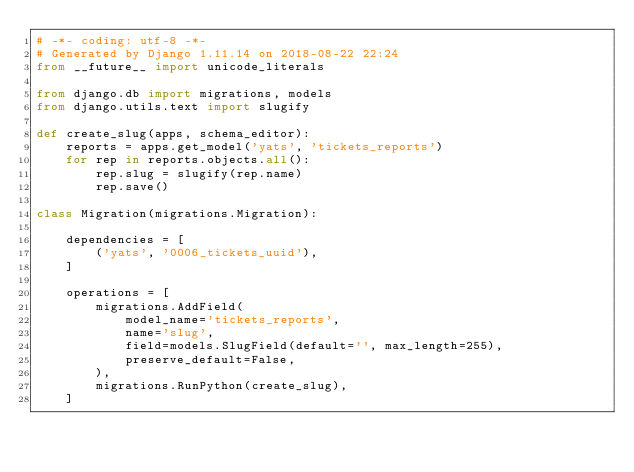Convert code to text. <code><loc_0><loc_0><loc_500><loc_500><_Python_># -*- coding: utf-8 -*-
# Generated by Django 1.11.14 on 2018-08-22 22:24
from __future__ import unicode_literals

from django.db import migrations, models
from django.utils.text import slugify

def create_slug(apps, schema_editor):
    reports = apps.get_model('yats', 'tickets_reports')
    for rep in reports.objects.all():
        rep.slug = slugify(rep.name)
        rep.save()

class Migration(migrations.Migration):

    dependencies = [
        ('yats', '0006_tickets_uuid'),
    ]

    operations = [
        migrations.AddField(
            model_name='tickets_reports',
            name='slug',
            field=models.SlugField(default='', max_length=255),
            preserve_default=False,
        ),
        migrations.RunPython(create_slug),
    ]
</code> 